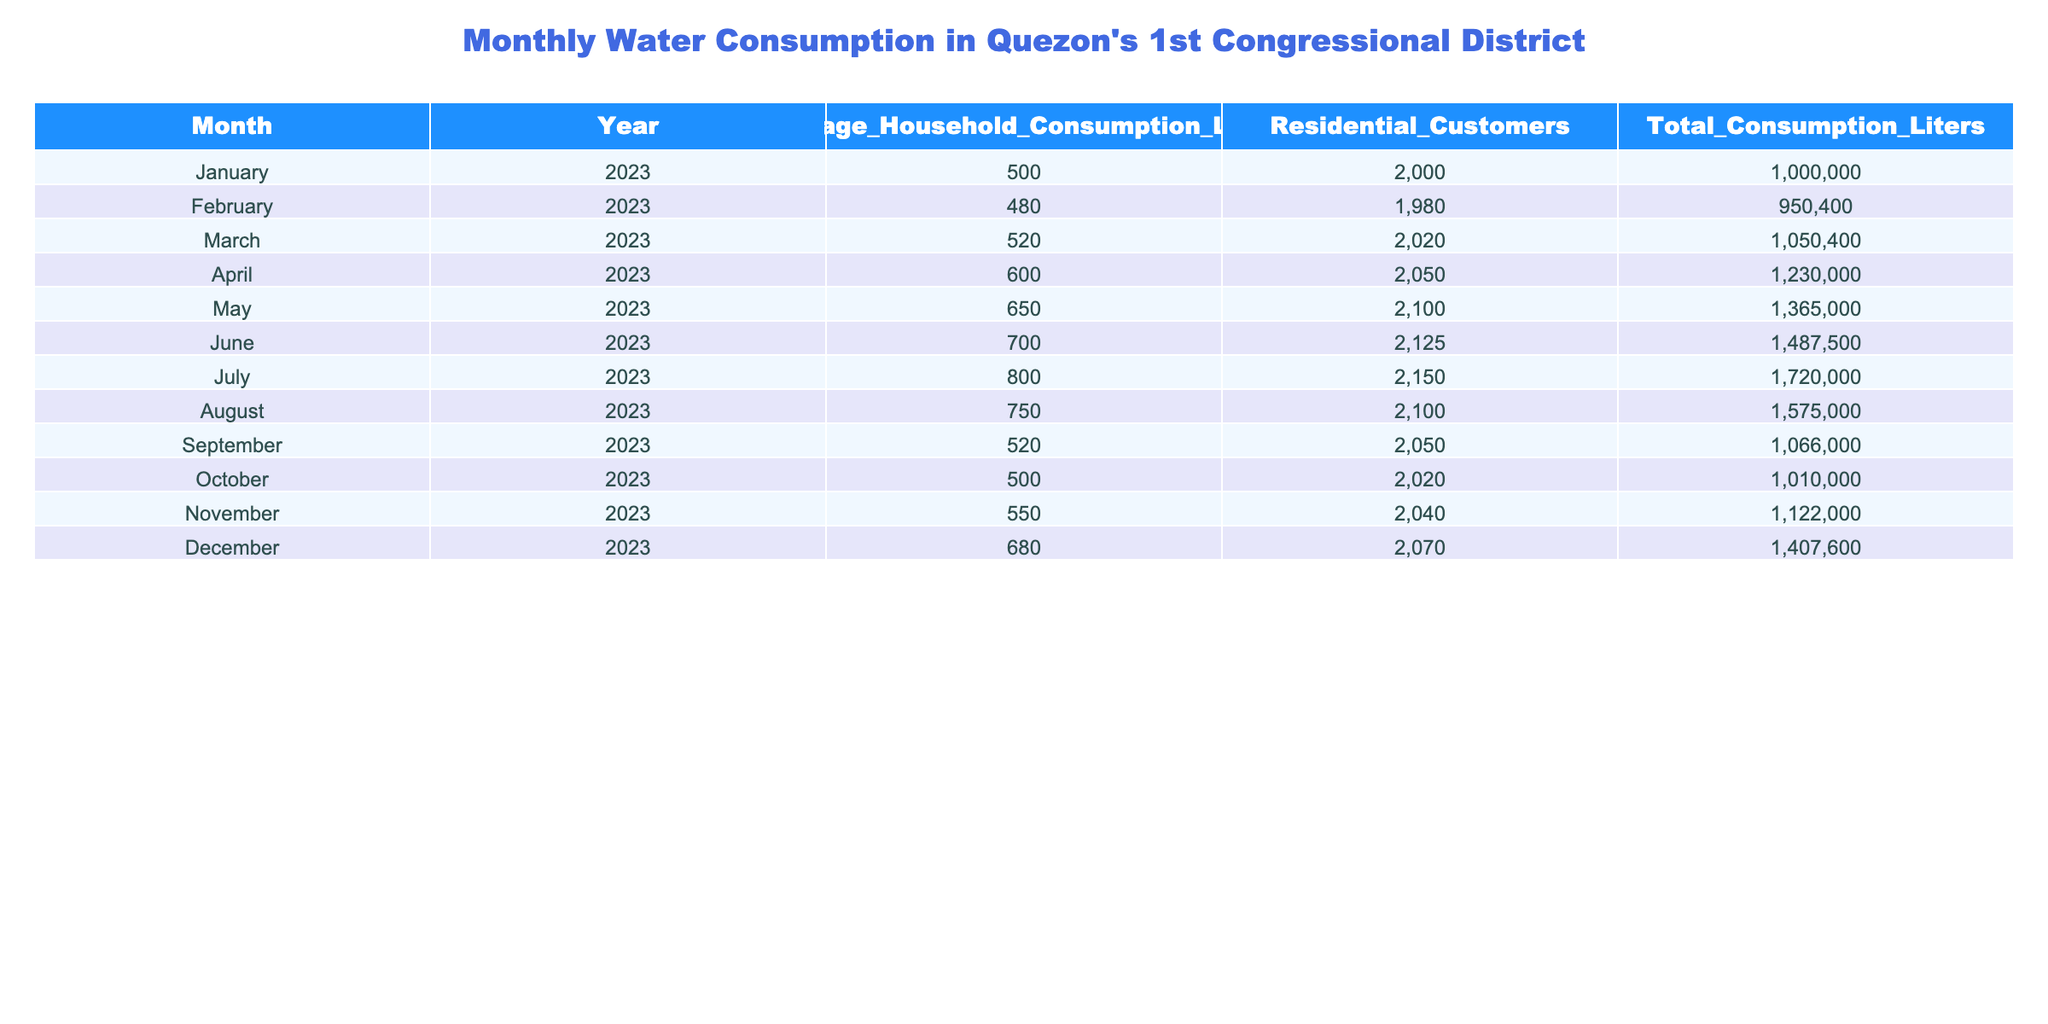What was the average household consumption in June 2023? By looking at the table, the average household consumption for June 2023 is directly listed under that month, which is 700 liters.
Answer: 700 liters What is the total water consumption in August 2023? The table shows that the total water consumption for August 2023 is directly given, which is 1,575,000 liters.
Answer: 1,575,000 liters In which month was the total consumption the highest? By comparing the total consumption values across all months in the table, we see that July 2023 has the highest total consumption at 1,720,000 liters.
Answer: July 2023 How many residential customers were there on average in the year 2023? To find the average number of residential customers for the year, we sum the values for each month (2000 + 1980 + 2020 + 2050 + 2100 + 2125 + 2150 + 2100 + 2050 + 2020 + 2040 + 2070) = 25,215, then divide by 12 (the number of months) to get approximately 2,100.
Answer: 2,100 customers Was there any month where the average household consumption was below 500 liters? Checking the table, the months of January, February, September, and October all have average household consumptions below 500 liters, making this statement true.
Answer: Yes What is the difference in total consumption between June and November 2023? The total consumption for June 2023 is 1,487,500 liters and for November 2023 is 1,122,000 liters. Subtracting these values gives 1,487,500 - 1,122,000 = 365,500 liters difference.
Answer: 365,500 liters How much did the average household consumption increase from January to April 2023? The average household consumption in January was 500 liters and in April it was 600 liters. The increase can be calculated as 600 - 500 = 100 liters.
Answer: 100 liters What month had the lowest average household consumption and what was that consumption? By reviewing the table, February 2023 has the lowest average household consumption of 480 liters.
Answer: February 2023, 480 liters If we consider only the first half of the year, what is the average total consumption? The total consumption for January to June is (1,000,000 + 950,400 + 1,050,400 + 1,230,000 + 1,365,000 + 1,487,500) = 7,083,300 liters. Dividing this by 6 months gives approximately 1,180,550 liters as the average total consumption for the first half of the year.
Answer: 1,180,550 liters In which month did the average household consumption surpass 700 liters for the first time? Examining the table, the average household consumption first surpassed 700 liters in June 2023 when it reached 700 liters.
Answer: June 2023 